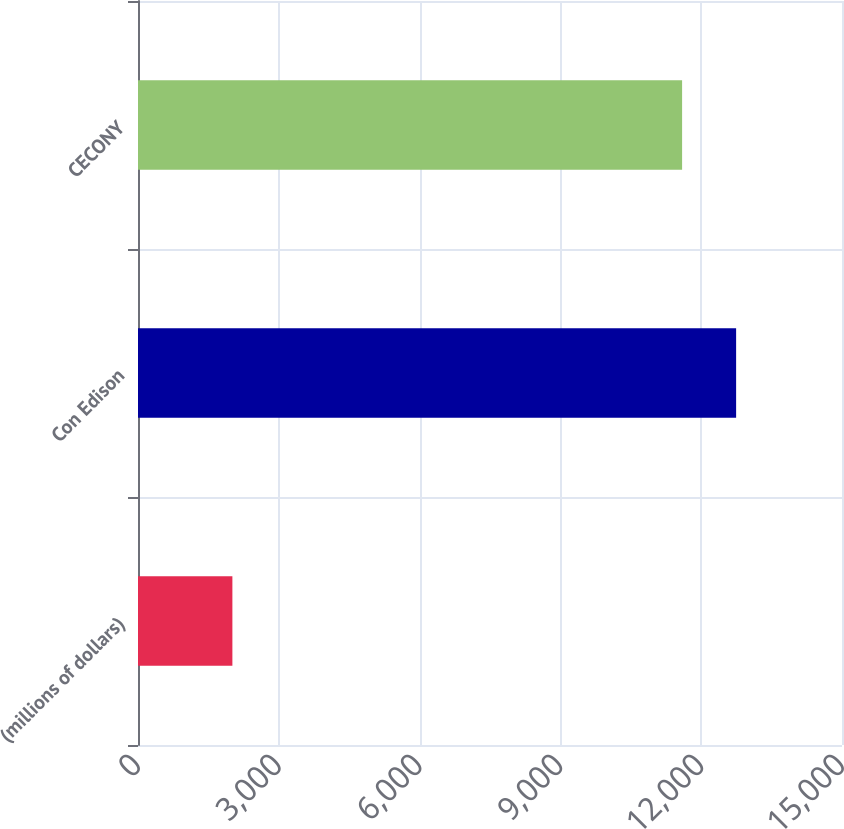<chart> <loc_0><loc_0><loc_500><loc_500><bar_chart><fcel>(millions of dollars)<fcel>Con Edison<fcel>CECONY<nl><fcel>2011<fcel>12744<fcel>11593<nl></chart> 